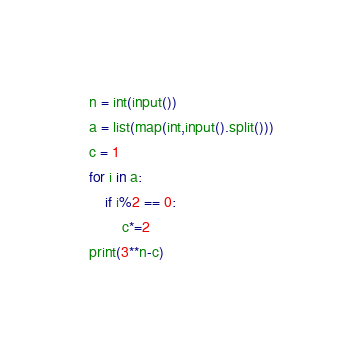<code> <loc_0><loc_0><loc_500><loc_500><_Python_>n = int(input())
a = list(map(int,input().split()))
c = 1
for i in a:
    if i%2 == 0:
        c*=2
print(3**n-c)</code> 